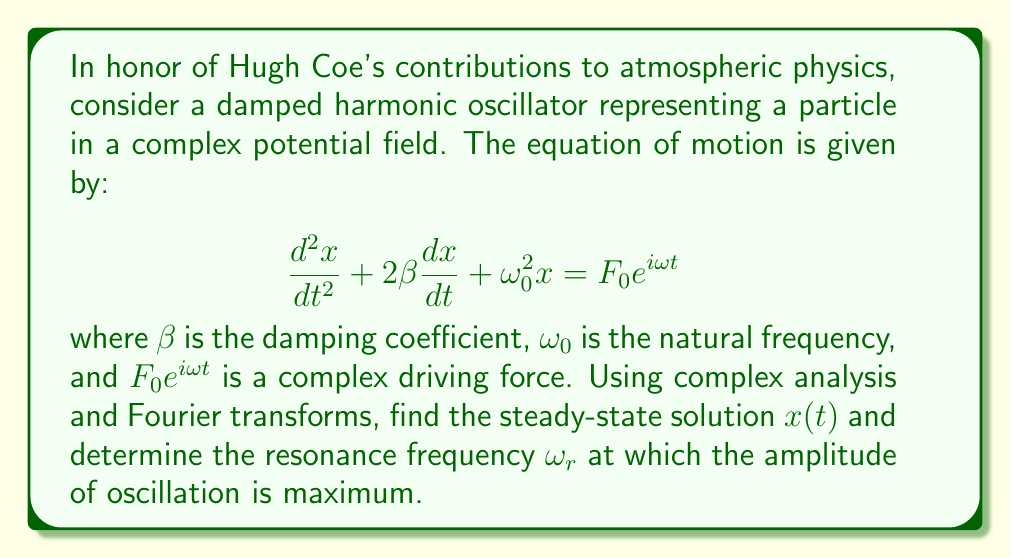Help me with this question. Let's approach this step-by-step:

1) First, we assume a steady-state solution of the form $x(t) = Ae^{i\omega t}$, where $A$ is a complex amplitude.

2) Substituting this into the equation of motion:

   $$(-\omega^2 + 2i\beta\omega + \omega_0^2)Ae^{i\omega t} = F_0e^{i\omega t}$$

3) Solving for $A$:

   $$A = \frac{F_0}{\omega_0^2 - \omega^2 + 2i\beta\omega}$$

4) The amplitude of oscillation is given by the magnitude of $A$:

   $$|A| = \frac{F_0}{\sqrt{(\omega_0^2 - \omega^2)^2 + 4\beta^2\omega^2}}$$

5) To find the resonance frequency $\omega_r$, we need to maximize $|A|$. This is equivalent to minimizing the denominator.

6) Let $y = (\omega_0^2 - \omega^2)^2 + 4\beta^2\omega^2$

7) Differentiating with respect to $\omega$ and setting to zero:

   $$\frac{dy}{d\omega} = -4(\omega_0^2 - \omega^2)\omega + 8\beta^2\omega = 0$$

8) Solving this equation:

   $$\omega^2(\omega_0^2 - \omega^2) = 2\beta^2\omega^2$$
   $$\omega_0^2\omega^2 - \omega^4 = 2\beta^2\omega^2$$
   $$\omega^4 - (\omega_0^2 - 2\beta^2)\omega^2 = 0$$

9) The non-zero solution is:

   $$\omega_r^2 = \omega_0^2 - 2\beta^2$$

10) Therefore, the resonance frequency is:

    $$\omega_r = \sqrt{\omega_0^2 - 2\beta^2}$$

Thus, the steady-state solution is $x(t) = Ae^{i\omega t}$ where $A = \frac{F_0}{\omega_0^2 - \omega^2 + 2i\beta\omega}$, and the resonance frequency is $\sqrt{\omega_0^2 - 2\beta^2}$.
Answer: $x(t) = \frac{F_0e^{i\omega t}}{\omega_0^2 - \omega^2 + 2i\beta\omega}$; $\omega_r = \sqrt{\omega_0^2 - 2\beta^2}$ 